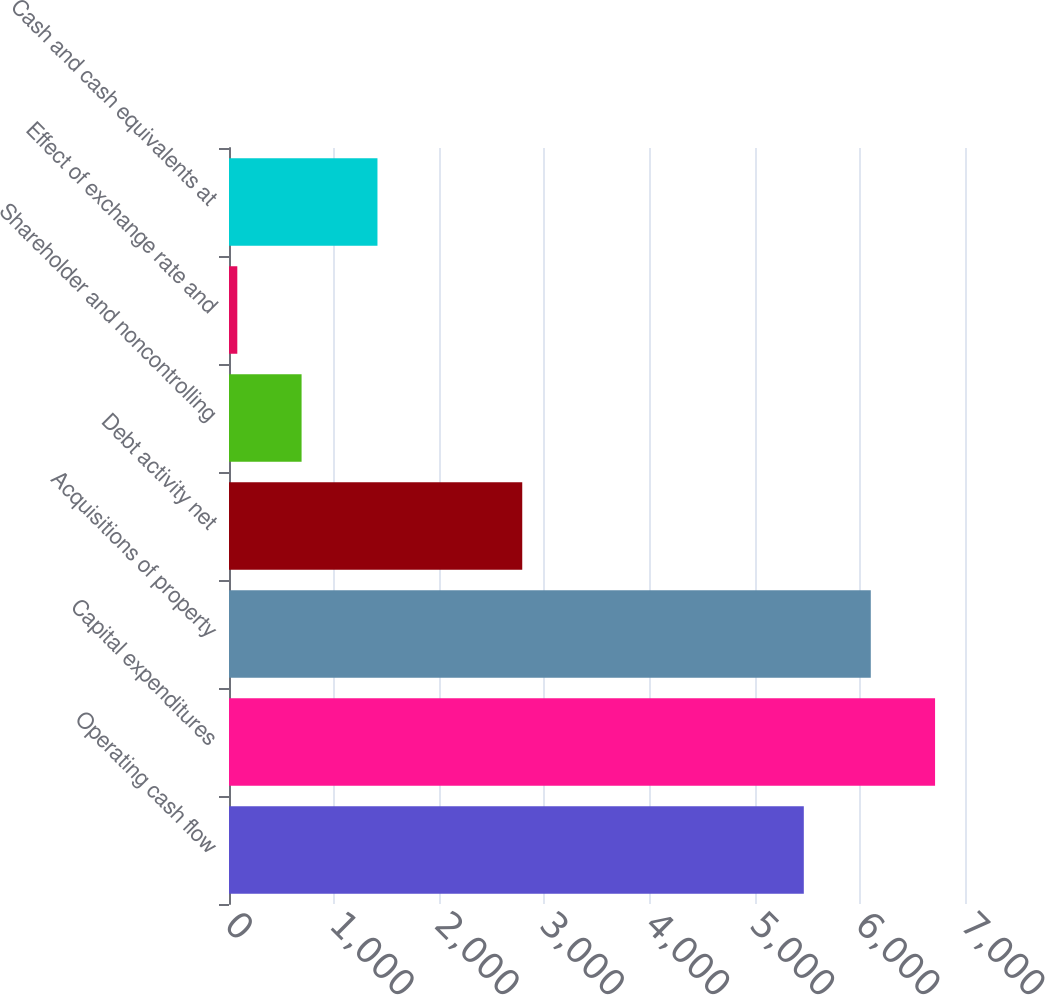<chart> <loc_0><loc_0><loc_500><loc_500><bar_chart><fcel>Operating cash flow<fcel>Capital expenditures<fcel>Acquisitions of property<fcel>Debt activity net<fcel>Shareholder and noncontrolling<fcel>Effect of exchange rate and<fcel>Cash and cash equivalents at<nl><fcel>5467<fcel>6715.3<fcel>6104<fcel>2789<fcel>690.3<fcel>79<fcel>1412<nl></chart> 